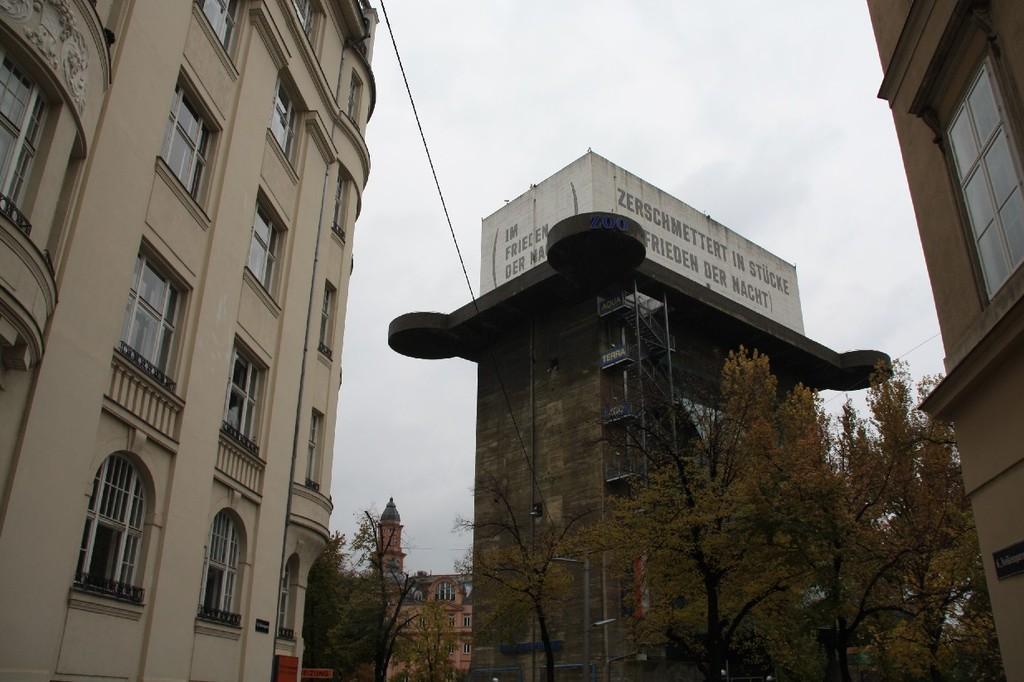Can you describe this image briefly? In this picture we can see trees, buildings with windows, name board, walls with some text on it, steps and in the background we can see the sky. 